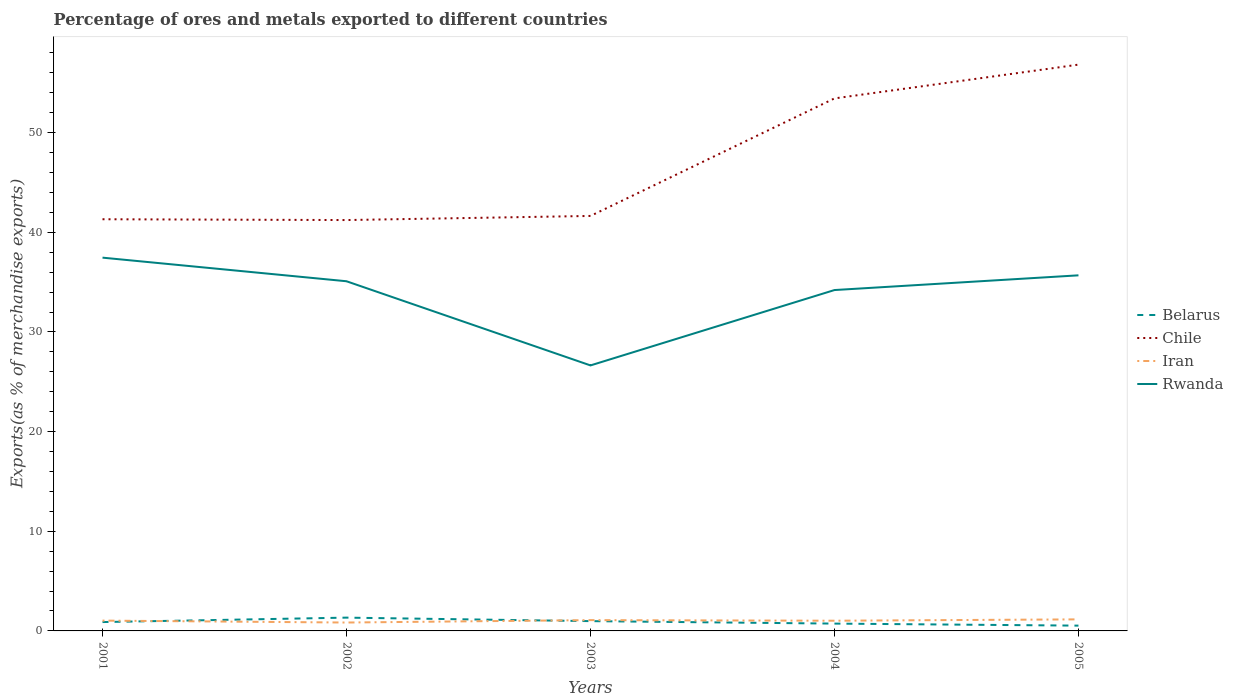Does the line corresponding to Chile intersect with the line corresponding to Belarus?
Give a very brief answer. No. Across all years, what is the maximum percentage of exports to different countries in Chile?
Offer a terse response. 41.23. What is the total percentage of exports to different countries in Belarus in the graph?
Give a very brief answer. 0.35. What is the difference between the highest and the second highest percentage of exports to different countries in Iran?
Ensure brevity in your answer.  0.32. What is the difference between the highest and the lowest percentage of exports to different countries in Rwanda?
Ensure brevity in your answer.  4. Is the percentage of exports to different countries in Iran strictly greater than the percentage of exports to different countries in Chile over the years?
Make the answer very short. Yes. What is the difference between two consecutive major ticks on the Y-axis?
Keep it short and to the point. 10. Are the values on the major ticks of Y-axis written in scientific E-notation?
Your answer should be compact. No. Does the graph contain any zero values?
Your response must be concise. No. Does the graph contain grids?
Keep it short and to the point. No. Where does the legend appear in the graph?
Provide a short and direct response. Center right. What is the title of the graph?
Ensure brevity in your answer.  Percentage of ores and metals exported to different countries. What is the label or title of the X-axis?
Offer a terse response. Years. What is the label or title of the Y-axis?
Your answer should be compact. Exports(as % of merchandise exports). What is the Exports(as % of merchandise exports) in Belarus in 2001?
Provide a short and direct response. 0.89. What is the Exports(as % of merchandise exports) in Chile in 2001?
Offer a very short reply. 41.31. What is the Exports(as % of merchandise exports) of Iran in 2001?
Make the answer very short. 1.03. What is the Exports(as % of merchandise exports) of Rwanda in 2001?
Provide a short and direct response. 37.46. What is the Exports(as % of merchandise exports) of Belarus in 2002?
Offer a terse response. 1.33. What is the Exports(as % of merchandise exports) in Chile in 2002?
Your response must be concise. 41.23. What is the Exports(as % of merchandise exports) in Iran in 2002?
Make the answer very short. 0.84. What is the Exports(as % of merchandise exports) in Rwanda in 2002?
Offer a terse response. 35.09. What is the Exports(as % of merchandise exports) in Belarus in 2003?
Your response must be concise. 0.98. What is the Exports(as % of merchandise exports) in Chile in 2003?
Make the answer very short. 41.64. What is the Exports(as % of merchandise exports) of Iran in 2003?
Your answer should be very brief. 1.08. What is the Exports(as % of merchandise exports) in Rwanda in 2003?
Your answer should be very brief. 26.64. What is the Exports(as % of merchandise exports) in Belarus in 2004?
Ensure brevity in your answer.  0.73. What is the Exports(as % of merchandise exports) of Chile in 2004?
Your answer should be compact. 53.44. What is the Exports(as % of merchandise exports) in Iran in 2004?
Your answer should be compact. 1.02. What is the Exports(as % of merchandise exports) in Rwanda in 2004?
Offer a very short reply. 34.21. What is the Exports(as % of merchandise exports) in Belarus in 2005?
Your response must be concise. 0.53. What is the Exports(as % of merchandise exports) in Chile in 2005?
Ensure brevity in your answer.  56.83. What is the Exports(as % of merchandise exports) of Iran in 2005?
Your response must be concise. 1.16. What is the Exports(as % of merchandise exports) of Rwanda in 2005?
Your answer should be very brief. 35.68. Across all years, what is the maximum Exports(as % of merchandise exports) of Belarus?
Ensure brevity in your answer.  1.33. Across all years, what is the maximum Exports(as % of merchandise exports) of Chile?
Ensure brevity in your answer.  56.83. Across all years, what is the maximum Exports(as % of merchandise exports) in Iran?
Offer a terse response. 1.16. Across all years, what is the maximum Exports(as % of merchandise exports) of Rwanda?
Provide a short and direct response. 37.46. Across all years, what is the minimum Exports(as % of merchandise exports) of Belarus?
Offer a terse response. 0.53. Across all years, what is the minimum Exports(as % of merchandise exports) in Chile?
Your response must be concise. 41.23. Across all years, what is the minimum Exports(as % of merchandise exports) in Iran?
Your response must be concise. 0.84. Across all years, what is the minimum Exports(as % of merchandise exports) of Rwanda?
Give a very brief answer. 26.64. What is the total Exports(as % of merchandise exports) in Belarus in the graph?
Ensure brevity in your answer.  4.47. What is the total Exports(as % of merchandise exports) in Chile in the graph?
Provide a succinct answer. 234.44. What is the total Exports(as % of merchandise exports) in Iran in the graph?
Your response must be concise. 5.14. What is the total Exports(as % of merchandise exports) in Rwanda in the graph?
Ensure brevity in your answer.  169.08. What is the difference between the Exports(as % of merchandise exports) in Belarus in 2001 and that in 2002?
Provide a short and direct response. -0.44. What is the difference between the Exports(as % of merchandise exports) of Chile in 2001 and that in 2002?
Ensure brevity in your answer.  0.08. What is the difference between the Exports(as % of merchandise exports) in Iran in 2001 and that in 2002?
Offer a terse response. 0.19. What is the difference between the Exports(as % of merchandise exports) of Rwanda in 2001 and that in 2002?
Ensure brevity in your answer.  2.37. What is the difference between the Exports(as % of merchandise exports) in Belarus in 2001 and that in 2003?
Make the answer very short. -0.09. What is the difference between the Exports(as % of merchandise exports) in Chile in 2001 and that in 2003?
Offer a very short reply. -0.33. What is the difference between the Exports(as % of merchandise exports) in Iran in 2001 and that in 2003?
Offer a terse response. -0.05. What is the difference between the Exports(as % of merchandise exports) in Rwanda in 2001 and that in 2003?
Make the answer very short. 10.81. What is the difference between the Exports(as % of merchandise exports) in Belarus in 2001 and that in 2004?
Give a very brief answer. 0.15. What is the difference between the Exports(as % of merchandise exports) of Chile in 2001 and that in 2004?
Offer a terse response. -12.13. What is the difference between the Exports(as % of merchandise exports) of Iran in 2001 and that in 2004?
Your answer should be very brief. 0.01. What is the difference between the Exports(as % of merchandise exports) of Rwanda in 2001 and that in 2004?
Make the answer very short. 3.25. What is the difference between the Exports(as % of merchandise exports) of Belarus in 2001 and that in 2005?
Offer a very short reply. 0.36. What is the difference between the Exports(as % of merchandise exports) of Chile in 2001 and that in 2005?
Your answer should be compact. -15.52. What is the difference between the Exports(as % of merchandise exports) in Iran in 2001 and that in 2005?
Your answer should be very brief. -0.13. What is the difference between the Exports(as % of merchandise exports) of Rwanda in 2001 and that in 2005?
Your response must be concise. 1.77. What is the difference between the Exports(as % of merchandise exports) in Belarus in 2002 and that in 2003?
Offer a terse response. 0.35. What is the difference between the Exports(as % of merchandise exports) in Chile in 2002 and that in 2003?
Keep it short and to the point. -0.41. What is the difference between the Exports(as % of merchandise exports) of Iran in 2002 and that in 2003?
Make the answer very short. -0.24. What is the difference between the Exports(as % of merchandise exports) in Rwanda in 2002 and that in 2003?
Make the answer very short. 8.45. What is the difference between the Exports(as % of merchandise exports) in Belarus in 2002 and that in 2004?
Offer a very short reply. 0.6. What is the difference between the Exports(as % of merchandise exports) of Chile in 2002 and that in 2004?
Provide a short and direct response. -12.21. What is the difference between the Exports(as % of merchandise exports) in Iran in 2002 and that in 2004?
Make the answer very short. -0.18. What is the difference between the Exports(as % of merchandise exports) of Rwanda in 2002 and that in 2004?
Make the answer very short. 0.88. What is the difference between the Exports(as % of merchandise exports) of Belarus in 2002 and that in 2005?
Your answer should be very brief. 0.8. What is the difference between the Exports(as % of merchandise exports) of Chile in 2002 and that in 2005?
Provide a succinct answer. -15.6. What is the difference between the Exports(as % of merchandise exports) in Iran in 2002 and that in 2005?
Provide a short and direct response. -0.32. What is the difference between the Exports(as % of merchandise exports) in Rwanda in 2002 and that in 2005?
Provide a short and direct response. -0.59. What is the difference between the Exports(as % of merchandise exports) of Belarus in 2003 and that in 2004?
Provide a short and direct response. 0.25. What is the difference between the Exports(as % of merchandise exports) of Chile in 2003 and that in 2004?
Your answer should be compact. -11.79. What is the difference between the Exports(as % of merchandise exports) in Iran in 2003 and that in 2004?
Your answer should be very brief. 0.06. What is the difference between the Exports(as % of merchandise exports) of Rwanda in 2003 and that in 2004?
Ensure brevity in your answer.  -7.56. What is the difference between the Exports(as % of merchandise exports) in Belarus in 2003 and that in 2005?
Offer a very short reply. 0.45. What is the difference between the Exports(as % of merchandise exports) of Chile in 2003 and that in 2005?
Your answer should be compact. -15.18. What is the difference between the Exports(as % of merchandise exports) in Iran in 2003 and that in 2005?
Your response must be concise. -0.08. What is the difference between the Exports(as % of merchandise exports) of Rwanda in 2003 and that in 2005?
Provide a succinct answer. -9.04. What is the difference between the Exports(as % of merchandise exports) of Belarus in 2004 and that in 2005?
Offer a terse response. 0.2. What is the difference between the Exports(as % of merchandise exports) of Chile in 2004 and that in 2005?
Give a very brief answer. -3.39. What is the difference between the Exports(as % of merchandise exports) of Iran in 2004 and that in 2005?
Ensure brevity in your answer.  -0.14. What is the difference between the Exports(as % of merchandise exports) in Rwanda in 2004 and that in 2005?
Your response must be concise. -1.48. What is the difference between the Exports(as % of merchandise exports) in Belarus in 2001 and the Exports(as % of merchandise exports) in Chile in 2002?
Your response must be concise. -40.34. What is the difference between the Exports(as % of merchandise exports) in Belarus in 2001 and the Exports(as % of merchandise exports) in Iran in 2002?
Provide a succinct answer. 0.05. What is the difference between the Exports(as % of merchandise exports) of Belarus in 2001 and the Exports(as % of merchandise exports) of Rwanda in 2002?
Make the answer very short. -34.2. What is the difference between the Exports(as % of merchandise exports) in Chile in 2001 and the Exports(as % of merchandise exports) in Iran in 2002?
Offer a terse response. 40.47. What is the difference between the Exports(as % of merchandise exports) in Chile in 2001 and the Exports(as % of merchandise exports) in Rwanda in 2002?
Your response must be concise. 6.22. What is the difference between the Exports(as % of merchandise exports) of Iran in 2001 and the Exports(as % of merchandise exports) of Rwanda in 2002?
Offer a very short reply. -34.05. What is the difference between the Exports(as % of merchandise exports) in Belarus in 2001 and the Exports(as % of merchandise exports) in Chile in 2003?
Keep it short and to the point. -40.75. What is the difference between the Exports(as % of merchandise exports) in Belarus in 2001 and the Exports(as % of merchandise exports) in Iran in 2003?
Give a very brief answer. -0.19. What is the difference between the Exports(as % of merchandise exports) of Belarus in 2001 and the Exports(as % of merchandise exports) of Rwanda in 2003?
Offer a very short reply. -25.75. What is the difference between the Exports(as % of merchandise exports) in Chile in 2001 and the Exports(as % of merchandise exports) in Iran in 2003?
Provide a succinct answer. 40.23. What is the difference between the Exports(as % of merchandise exports) in Chile in 2001 and the Exports(as % of merchandise exports) in Rwanda in 2003?
Ensure brevity in your answer.  14.67. What is the difference between the Exports(as % of merchandise exports) of Iran in 2001 and the Exports(as % of merchandise exports) of Rwanda in 2003?
Give a very brief answer. -25.61. What is the difference between the Exports(as % of merchandise exports) of Belarus in 2001 and the Exports(as % of merchandise exports) of Chile in 2004?
Your answer should be very brief. -52.55. What is the difference between the Exports(as % of merchandise exports) in Belarus in 2001 and the Exports(as % of merchandise exports) in Iran in 2004?
Your answer should be compact. -0.13. What is the difference between the Exports(as % of merchandise exports) of Belarus in 2001 and the Exports(as % of merchandise exports) of Rwanda in 2004?
Provide a short and direct response. -33.32. What is the difference between the Exports(as % of merchandise exports) of Chile in 2001 and the Exports(as % of merchandise exports) of Iran in 2004?
Ensure brevity in your answer.  40.29. What is the difference between the Exports(as % of merchandise exports) in Chile in 2001 and the Exports(as % of merchandise exports) in Rwanda in 2004?
Make the answer very short. 7.11. What is the difference between the Exports(as % of merchandise exports) of Iran in 2001 and the Exports(as % of merchandise exports) of Rwanda in 2004?
Your answer should be very brief. -33.17. What is the difference between the Exports(as % of merchandise exports) in Belarus in 2001 and the Exports(as % of merchandise exports) in Chile in 2005?
Your answer should be very brief. -55.94. What is the difference between the Exports(as % of merchandise exports) of Belarus in 2001 and the Exports(as % of merchandise exports) of Iran in 2005?
Give a very brief answer. -0.27. What is the difference between the Exports(as % of merchandise exports) of Belarus in 2001 and the Exports(as % of merchandise exports) of Rwanda in 2005?
Ensure brevity in your answer.  -34.79. What is the difference between the Exports(as % of merchandise exports) of Chile in 2001 and the Exports(as % of merchandise exports) of Iran in 2005?
Provide a short and direct response. 40.15. What is the difference between the Exports(as % of merchandise exports) of Chile in 2001 and the Exports(as % of merchandise exports) of Rwanda in 2005?
Ensure brevity in your answer.  5.63. What is the difference between the Exports(as % of merchandise exports) of Iran in 2001 and the Exports(as % of merchandise exports) of Rwanda in 2005?
Give a very brief answer. -34.65. What is the difference between the Exports(as % of merchandise exports) of Belarus in 2002 and the Exports(as % of merchandise exports) of Chile in 2003?
Ensure brevity in your answer.  -40.31. What is the difference between the Exports(as % of merchandise exports) in Belarus in 2002 and the Exports(as % of merchandise exports) in Iran in 2003?
Give a very brief answer. 0.25. What is the difference between the Exports(as % of merchandise exports) in Belarus in 2002 and the Exports(as % of merchandise exports) in Rwanda in 2003?
Provide a short and direct response. -25.31. What is the difference between the Exports(as % of merchandise exports) in Chile in 2002 and the Exports(as % of merchandise exports) in Iran in 2003?
Keep it short and to the point. 40.15. What is the difference between the Exports(as % of merchandise exports) of Chile in 2002 and the Exports(as % of merchandise exports) of Rwanda in 2003?
Offer a very short reply. 14.59. What is the difference between the Exports(as % of merchandise exports) in Iran in 2002 and the Exports(as % of merchandise exports) in Rwanda in 2003?
Give a very brief answer. -25.8. What is the difference between the Exports(as % of merchandise exports) in Belarus in 2002 and the Exports(as % of merchandise exports) in Chile in 2004?
Your response must be concise. -52.1. What is the difference between the Exports(as % of merchandise exports) in Belarus in 2002 and the Exports(as % of merchandise exports) in Iran in 2004?
Offer a terse response. 0.31. What is the difference between the Exports(as % of merchandise exports) in Belarus in 2002 and the Exports(as % of merchandise exports) in Rwanda in 2004?
Give a very brief answer. -32.87. What is the difference between the Exports(as % of merchandise exports) of Chile in 2002 and the Exports(as % of merchandise exports) of Iran in 2004?
Ensure brevity in your answer.  40.21. What is the difference between the Exports(as % of merchandise exports) of Chile in 2002 and the Exports(as % of merchandise exports) of Rwanda in 2004?
Offer a very short reply. 7.02. What is the difference between the Exports(as % of merchandise exports) of Iran in 2002 and the Exports(as % of merchandise exports) of Rwanda in 2004?
Your answer should be very brief. -33.36. What is the difference between the Exports(as % of merchandise exports) of Belarus in 2002 and the Exports(as % of merchandise exports) of Chile in 2005?
Provide a short and direct response. -55.49. What is the difference between the Exports(as % of merchandise exports) of Belarus in 2002 and the Exports(as % of merchandise exports) of Iran in 2005?
Make the answer very short. 0.17. What is the difference between the Exports(as % of merchandise exports) in Belarus in 2002 and the Exports(as % of merchandise exports) in Rwanda in 2005?
Your answer should be very brief. -34.35. What is the difference between the Exports(as % of merchandise exports) in Chile in 2002 and the Exports(as % of merchandise exports) in Iran in 2005?
Ensure brevity in your answer.  40.07. What is the difference between the Exports(as % of merchandise exports) in Chile in 2002 and the Exports(as % of merchandise exports) in Rwanda in 2005?
Your answer should be very brief. 5.55. What is the difference between the Exports(as % of merchandise exports) of Iran in 2002 and the Exports(as % of merchandise exports) of Rwanda in 2005?
Your answer should be very brief. -34.84. What is the difference between the Exports(as % of merchandise exports) of Belarus in 2003 and the Exports(as % of merchandise exports) of Chile in 2004?
Keep it short and to the point. -52.45. What is the difference between the Exports(as % of merchandise exports) of Belarus in 2003 and the Exports(as % of merchandise exports) of Iran in 2004?
Offer a terse response. -0.04. What is the difference between the Exports(as % of merchandise exports) in Belarus in 2003 and the Exports(as % of merchandise exports) in Rwanda in 2004?
Offer a terse response. -33.22. What is the difference between the Exports(as % of merchandise exports) in Chile in 2003 and the Exports(as % of merchandise exports) in Iran in 2004?
Provide a short and direct response. 40.62. What is the difference between the Exports(as % of merchandise exports) of Chile in 2003 and the Exports(as % of merchandise exports) of Rwanda in 2004?
Offer a terse response. 7.44. What is the difference between the Exports(as % of merchandise exports) of Iran in 2003 and the Exports(as % of merchandise exports) of Rwanda in 2004?
Offer a terse response. -33.12. What is the difference between the Exports(as % of merchandise exports) of Belarus in 2003 and the Exports(as % of merchandise exports) of Chile in 2005?
Provide a short and direct response. -55.84. What is the difference between the Exports(as % of merchandise exports) in Belarus in 2003 and the Exports(as % of merchandise exports) in Iran in 2005?
Make the answer very short. -0.18. What is the difference between the Exports(as % of merchandise exports) of Belarus in 2003 and the Exports(as % of merchandise exports) of Rwanda in 2005?
Your response must be concise. -34.7. What is the difference between the Exports(as % of merchandise exports) in Chile in 2003 and the Exports(as % of merchandise exports) in Iran in 2005?
Provide a short and direct response. 40.48. What is the difference between the Exports(as % of merchandise exports) of Chile in 2003 and the Exports(as % of merchandise exports) of Rwanda in 2005?
Your answer should be compact. 5.96. What is the difference between the Exports(as % of merchandise exports) in Iran in 2003 and the Exports(as % of merchandise exports) in Rwanda in 2005?
Ensure brevity in your answer.  -34.6. What is the difference between the Exports(as % of merchandise exports) in Belarus in 2004 and the Exports(as % of merchandise exports) in Chile in 2005?
Provide a succinct answer. -56.09. What is the difference between the Exports(as % of merchandise exports) in Belarus in 2004 and the Exports(as % of merchandise exports) in Iran in 2005?
Keep it short and to the point. -0.42. What is the difference between the Exports(as % of merchandise exports) of Belarus in 2004 and the Exports(as % of merchandise exports) of Rwanda in 2005?
Offer a terse response. -34.95. What is the difference between the Exports(as % of merchandise exports) in Chile in 2004 and the Exports(as % of merchandise exports) in Iran in 2005?
Give a very brief answer. 52.28. What is the difference between the Exports(as % of merchandise exports) of Chile in 2004 and the Exports(as % of merchandise exports) of Rwanda in 2005?
Your answer should be very brief. 17.75. What is the difference between the Exports(as % of merchandise exports) in Iran in 2004 and the Exports(as % of merchandise exports) in Rwanda in 2005?
Ensure brevity in your answer.  -34.66. What is the average Exports(as % of merchandise exports) in Belarus per year?
Offer a very short reply. 0.89. What is the average Exports(as % of merchandise exports) of Chile per year?
Provide a short and direct response. 46.89. What is the average Exports(as % of merchandise exports) in Iran per year?
Your answer should be compact. 1.03. What is the average Exports(as % of merchandise exports) in Rwanda per year?
Give a very brief answer. 33.82. In the year 2001, what is the difference between the Exports(as % of merchandise exports) of Belarus and Exports(as % of merchandise exports) of Chile?
Provide a succinct answer. -40.42. In the year 2001, what is the difference between the Exports(as % of merchandise exports) of Belarus and Exports(as % of merchandise exports) of Iran?
Offer a very short reply. -0.15. In the year 2001, what is the difference between the Exports(as % of merchandise exports) of Belarus and Exports(as % of merchandise exports) of Rwanda?
Your answer should be very brief. -36.57. In the year 2001, what is the difference between the Exports(as % of merchandise exports) of Chile and Exports(as % of merchandise exports) of Iran?
Offer a terse response. 40.28. In the year 2001, what is the difference between the Exports(as % of merchandise exports) of Chile and Exports(as % of merchandise exports) of Rwanda?
Keep it short and to the point. 3.85. In the year 2001, what is the difference between the Exports(as % of merchandise exports) of Iran and Exports(as % of merchandise exports) of Rwanda?
Offer a very short reply. -36.42. In the year 2002, what is the difference between the Exports(as % of merchandise exports) in Belarus and Exports(as % of merchandise exports) in Chile?
Make the answer very short. -39.9. In the year 2002, what is the difference between the Exports(as % of merchandise exports) in Belarus and Exports(as % of merchandise exports) in Iran?
Ensure brevity in your answer.  0.49. In the year 2002, what is the difference between the Exports(as % of merchandise exports) in Belarus and Exports(as % of merchandise exports) in Rwanda?
Give a very brief answer. -33.75. In the year 2002, what is the difference between the Exports(as % of merchandise exports) of Chile and Exports(as % of merchandise exports) of Iran?
Your answer should be compact. 40.39. In the year 2002, what is the difference between the Exports(as % of merchandise exports) in Chile and Exports(as % of merchandise exports) in Rwanda?
Your response must be concise. 6.14. In the year 2002, what is the difference between the Exports(as % of merchandise exports) of Iran and Exports(as % of merchandise exports) of Rwanda?
Offer a terse response. -34.25. In the year 2003, what is the difference between the Exports(as % of merchandise exports) of Belarus and Exports(as % of merchandise exports) of Chile?
Ensure brevity in your answer.  -40.66. In the year 2003, what is the difference between the Exports(as % of merchandise exports) of Belarus and Exports(as % of merchandise exports) of Iran?
Provide a succinct answer. -0.1. In the year 2003, what is the difference between the Exports(as % of merchandise exports) in Belarus and Exports(as % of merchandise exports) in Rwanda?
Make the answer very short. -25.66. In the year 2003, what is the difference between the Exports(as % of merchandise exports) in Chile and Exports(as % of merchandise exports) in Iran?
Your response must be concise. 40.56. In the year 2003, what is the difference between the Exports(as % of merchandise exports) of Chile and Exports(as % of merchandise exports) of Rwanda?
Offer a terse response. 15. In the year 2003, what is the difference between the Exports(as % of merchandise exports) in Iran and Exports(as % of merchandise exports) in Rwanda?
Your answer should be very brief. -25.56. In the year 2004, what is the difference between the Exports(as % of merchandise exports) of Belarus and Exports(as % of merchandise exports) of Chile?
Your answer should be compact. -52.7. In the year 2004, what is the difference between the Exports(as % of merchandise exports) of Belarus and Exports(as % of merchandise exports) of Iran?
Keep it short and to the point. -0.29. In the year 2004, what is the difference between the Exports(as % of merchandise exports) in Belarus and Exports(as % of merchandise exports) in Rwanda?
Ensure brevity in your answer.  -33.47. In the year 2004, what is the difference between the Exports(as % of merchandise exports) in Chile and Exports(as % of merchandise exports) in Iran?
Make the answer very short. 52.41. In the year 2004, what is the difference between the Exports(as % of merchandise exports) of Chile and Exports(as % of merchandise exports) of Rwanda?
Keep it short and to the point. 19.23. In the year 2004, what is the difference between the Exports(as % of merchandise exports) of Iran and Exports(as % of merchandise exports) of Rwanda?
Ensure brevity in your answer.  -33.18. In the year 2005, what is the difference between the Exports(as % of merchandise exports) of Belarus and Exports(as % of merchandise exports) of Chile?
Make the answer very short. -56.29. In the year 2005, what is the difference between the Exports(as % of merchandise exports) in Belarus and Exports(as % of merchandise exports) in Iran?
Your response must be concise. -0.63. In the year 2005, what is the difference between the Exports(as % of merchandise exports) in Belarus and Exports(as % of merchandise exports) in Rwanda?
Offer a terse response. -35.15. In the year 2005, what is the difference between the Exports(as % of merchandise exports) in Chile and Exports(as % of merchandise exports) in Iran?
Make the answer very short. 55.67. In the year 2005, what is the difference between the Exports(as % of merchandise exports) in Chile and Exports(as % of merchandise exports) in Rwanda?
Your answer should be very brief. 21.14. In the year 2005, what is the difference between the Exports(as % of merchandise exports) in Iran and Exports(as % of merchandise exports) in Rwanda?
Offer a very short reply. -34.52. What is the ratio of the Exports(as % of merchandise exports) in Belarus in 2001 to that in 2002?
Provide a short and direct response. 0.67. What is the ratio of the Exports(as % of merchandise exports) of Iran in 2001 to that in 2002?
Your response must be concise. 1.23. What is the ratio of the Exports(as % of merchandise exports) of Rwanda in 2001 to that in 2002?
Offer a very short reply. 1.07. What is the ratio of the Exports(as % of merchandise exports) in Belarus in 2001 to that in 2003?
Offer a terse response. 0.9. What is the ratio of the Exports(as % of merchandise exports) of Chile in 2001 to that in 2003?
Provide a succinct answer. 0.99. What is the ratio of the Exports(as % of merchandise exports) in Iran in 2001 to that in 2003?
Your answer should be compact. 0.95. What is the ratio of the Exports(as % of merchandise exports) of Rwanda in 2001 to that in 2003?
Give a very brief answer. 1.41. What is the ratio of the Exports(as % of merchandise exports) of Belarus in 2001 to that in 2004?
Provide a short and direct response. 1.21. What is the ratio of the Exports(as % of merchandise exports) of Chile in 2001 to that in 2004?
Your response must be concise. 0.77. What is the ratio of the Exports(as % of merchandise exports) of Iran in 2001 to that in 2004?
Provide a short and direct response. 1.01. What is the ratio of the Exports(as % of merchandise exports) of Rwanda in 2001 to that in 2004?
Your response must be concise. 1.1. What is the ratio of the Exports(as % of merchandise exports) in Belarus in 2001 to that in 2005?
Keep it short and to the point. 1.67. What is the ratio of the Exports(as % of merchandise exports) of Chile in 2001 to that in 2005?
Ensure brevity in your answer.  0.73. What is the ratio of the Exports(as % of merchandise exports) in Iran in 2001 to that in 2005?
Keep it short and to the point. 0.89. What is the ratio of the Exports(as % of merchandise exports) of Rwanda in 2001 to that in 2005?
Provide a short and direct response. 1.05. What is the ratio of the Exports(as % of merchandise exports) of Belarus in 2002 to that in 2003?
Provide a short and direct response. 1.36. What is the ratio of the Exports(as % of merchandise exports) of Chile in 2002 to that in 2003?
Your answer should be very brief. 0.99. What is the ratio of the Exports(as % of merchandise exports) in Iran in 2002 to that in 2003?
Provide a succinct answer. 0.78. What is the ratio of the Exports(as % of merchandise exports) in Rwanda in 2002 to that in 2003?
Keep it short and to the point. 1.32. What is the ratio of the Exports(as % of merchandise exports) of Belarus in 2002 to that in 2004?
Your answer should be compact. 1.81. What is the ratio of the Exports(as % of merchandise exports) of Chile in 2002 to that in 2004?
Provide a short and direct response. 0.77. What is the ratio of the Exports(as % of merchandise exports) of Iran in 2002 to that in 2004?
Give a very brief answer. 0.82. What is the ratio of the Exports(as % of merchandise exports) in Rwanda in 2002 to that in 2004?
Keep it short and to the point. 1.03. What is the ratio of the Exports(as % of merchandise exports) of Belarus in 2002 to that in 2005?
Your answer should be compact. 2.51. What is the ratio of the Exports(as % of merchandise exports) in Chile in 2002 to that in 2005?
Your response must be concise. 0.73. What is the ratio of the Exports(as % of merchandise exports) in Iran in 2002 to that in 2005?
Provide a short and direct response. 0.73. What is the ratio of the Exports(as % of merchandise exports) in Rwanda in 2002 to that in 2005?
Give a very brief answer. 0.98. What is the ratio of the Exports(as % of merchandise exports) of Belarus in 2003 to that in 2004?
Keep it short and to the point. 1.34. What is the ratio of the Exports(as % of merchandise exports) in Chile in 2003 to that in 2004?
Provide a succinct answer. 0.78. What is the ratio of the Exports(as % of merchandise exports) in Iran in 2003 to that in 2004?
Offer a terse response. 1.06. What is the ratio of the Exports(as % of merchandise exports) of Rwanda in 2003 to that in 2004?
Your answer should be very brief. 0.78. What is the ratio of the Exports(as % of merchandise exports) in Belarus in 2003 to that in 2005?
Ensure brevity in your answer.  1.85. What is the ratio of the Exports(as % of merchandise exports) of Chile in 2003 to that in 2005?
Offer a very short reply. 0.73. What is the ratio of the Exports(as % of merchandise exports) of Iran in 2003 to that in 2005?
Offer a very short reply. 0.93. What is the ratio of the Exports(as % of merchandise exports) of Rwanda in 2003 to that in 2005?
Your answer should be compact. 0.75. What is the ratio of the Exports(as % of merchandise exports) in Belarus in 2004 to that in 2005?
Offer a very short reply. 1.38. What is the ratio of the Exports(as % of merchandise exports) in Chile in 2004 to that in 2005?
Offer a terse response. 0.94. What is the ratio of the Exports(as % of merchandise exports) of Iran in 2004 to that in 2005?
Ensure brevity in your answer.  0.88. What is the ratio of the Exports(as % of merchandise exports) in Rwanda in 2004 to that in 2005?
Make the answer very short. 0.96. What is the difference between the highest and the second highest Exports(as % of merchandise exports) of Belarus?
Make the answer very short. 0.35. What is the difference between the highest and the second highest Exports(as % of merchandise exports) in Chile?
Make the answer very short. 3.39. What is the difference between the highest and the second highest Exports(as % of merchandise exports) in Iran?
Provide a short and direct response. 0.08. What is the difference between the highest and the second highest Exports(as % of merchandise exports) in Rwanda?
Your answer should be very brief. 1.77. What is the difference between the highest and the lowest Exports(as % of merchandise exports) in Belarus?
Your answer should be very brief. 0.8. What is the difference between the highest and the lowest Exports(as % of merchandise exports) of Chile?
Give a very brief answer. 15.6. What is the difference between the highest and the lowest Exports(as % of merchandise exports) of Iran?
Ensure brevity in your answer.  0.32. What is the difference between the highest and the lowest Exports(as % of merchandise exports) of Rwanda?
Offer a terse response. 10.81. 